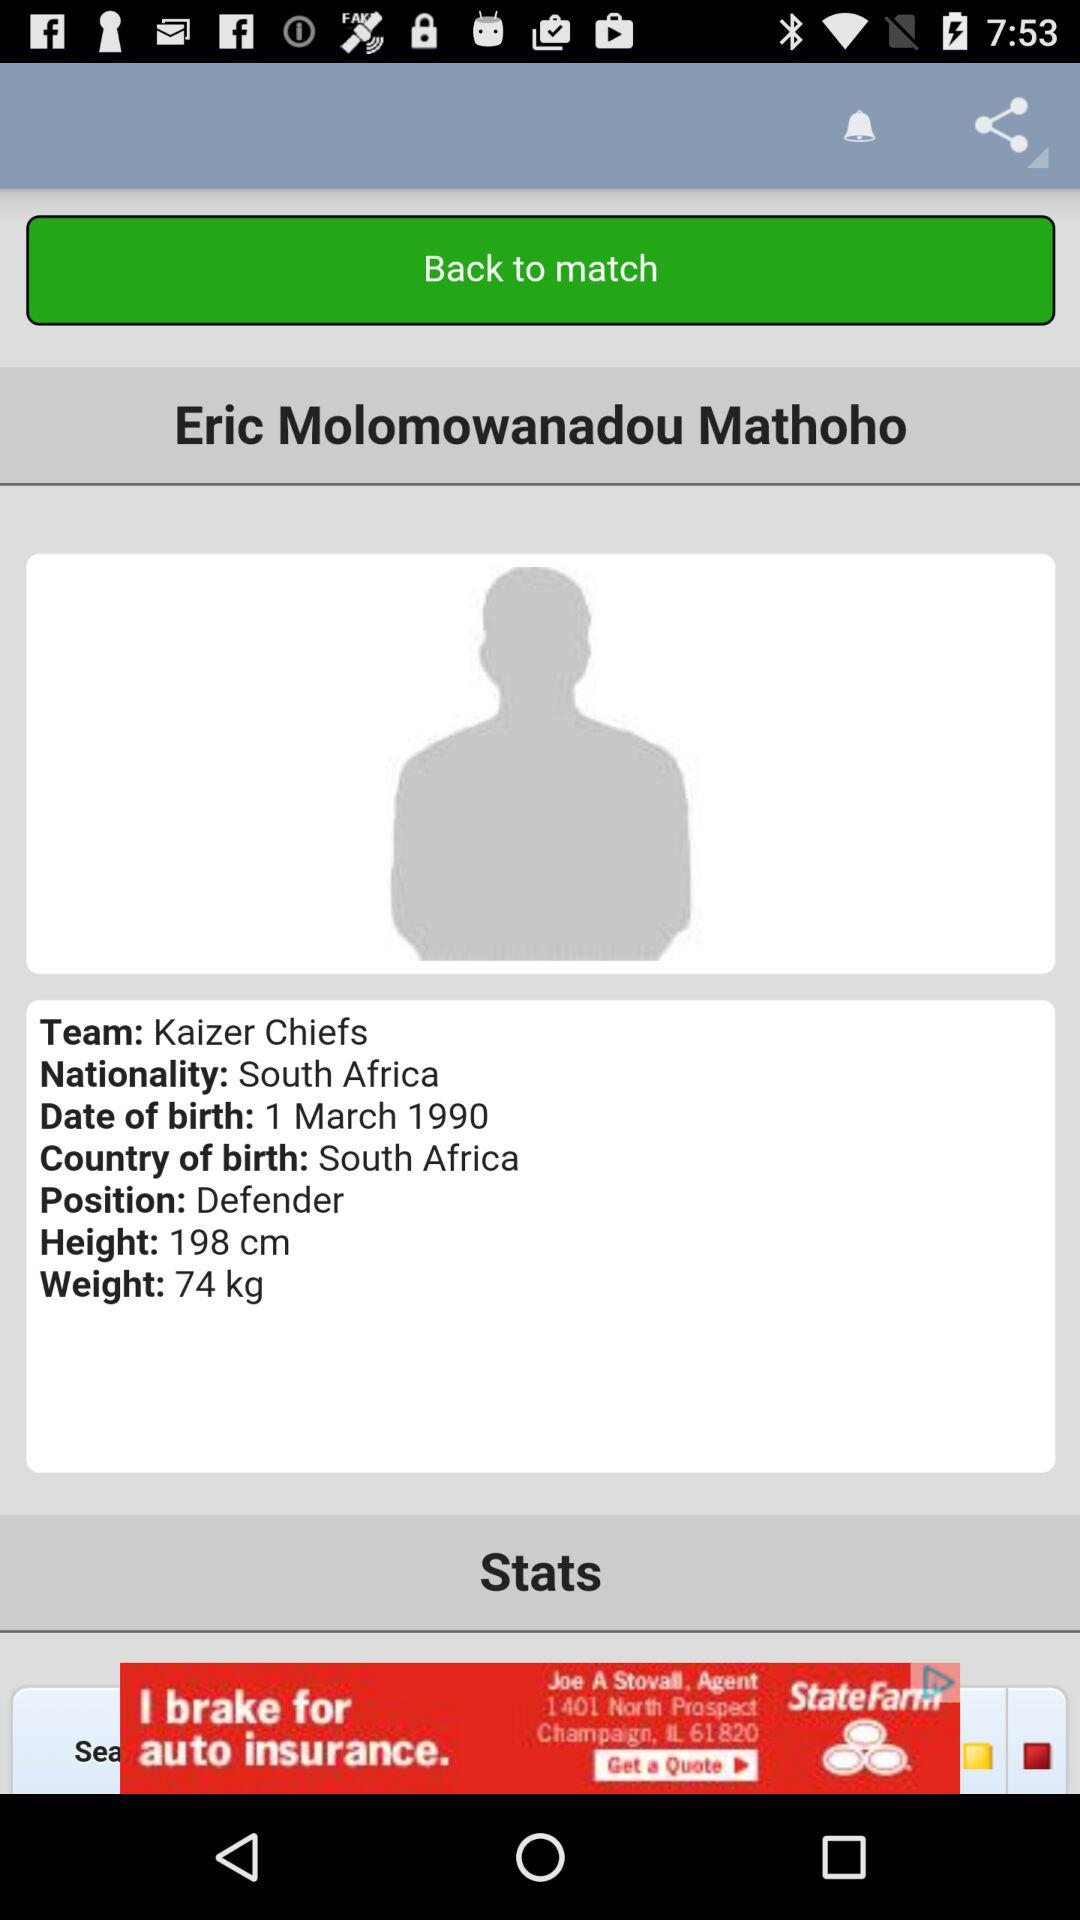What is the nationality? The nationality is South Africa. 